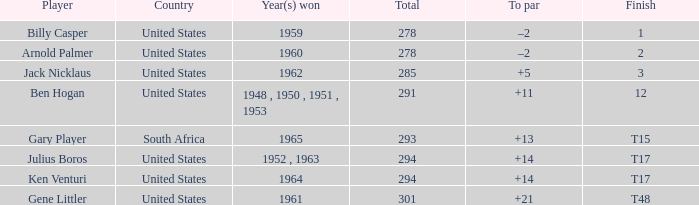Identify the country that was victorious in 1962. United States. 